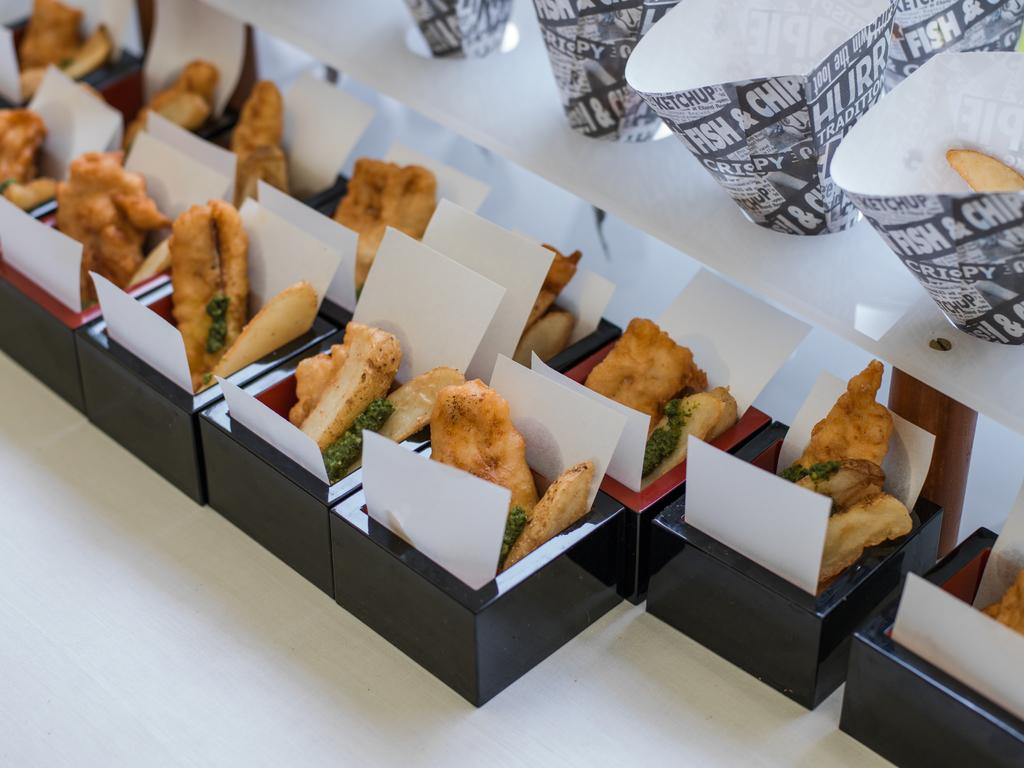What color are the boxes in the image? The boxes in the image are black. What items can be found inside the boxes? The boxes contain food items and tissues. What other items can be seen in the image besides the boxes? There are paper cups visible in the image. What else is present in the image besides the boxes and paper cups? There are additional food items in the image. What level of the building is the minister located in the image? There is no minister or building present in the image; it features black color boxes containing food items and tissues, along with paper cups and additional food items. 